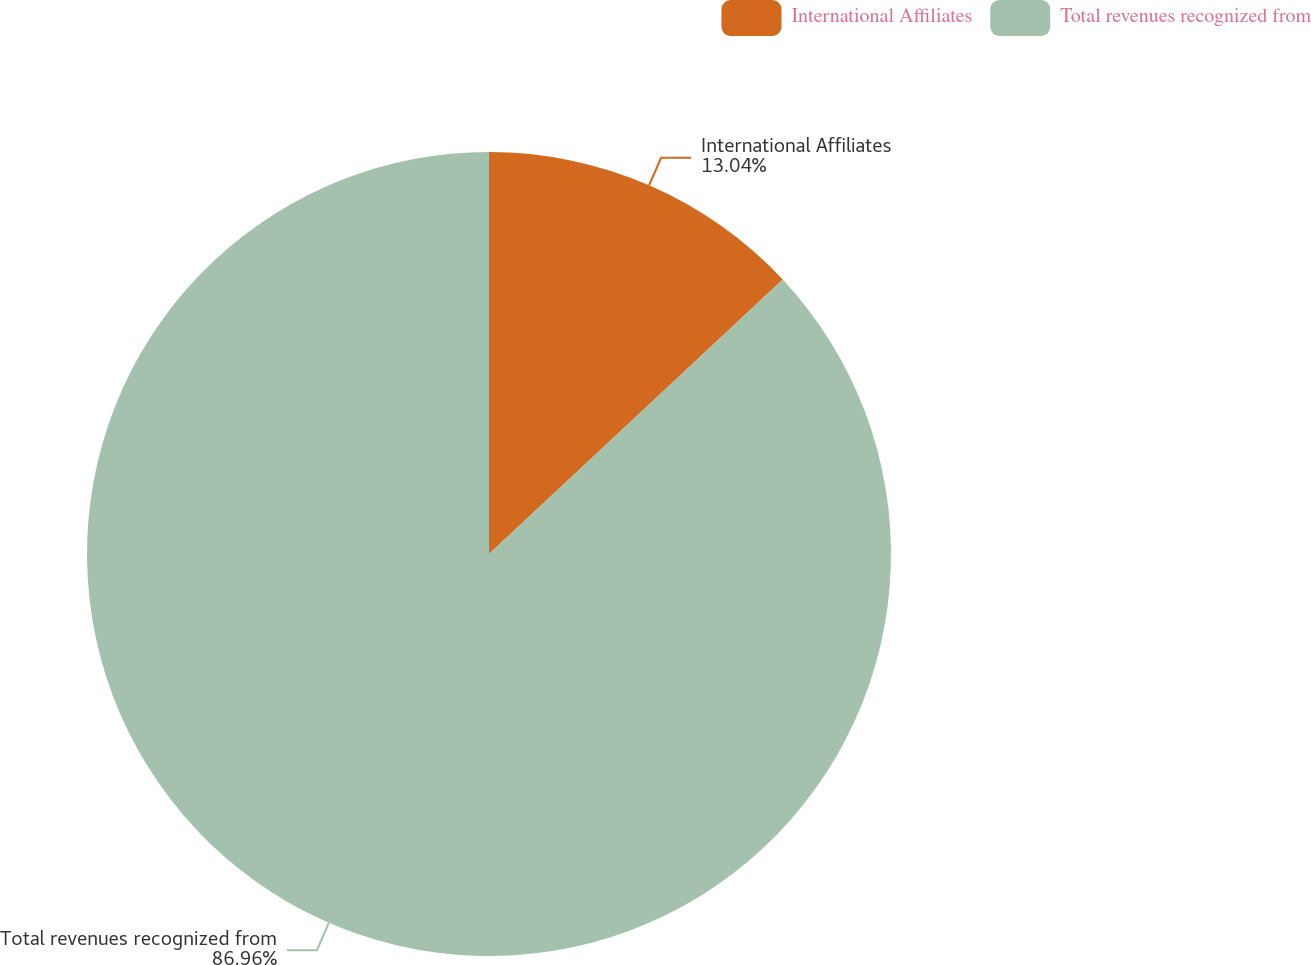Convert chart to OTSL. <chart><loc_0><loc_0><loc_500><loc_500><pie_chart><fcel>International Affiliates<fcel>Total revenues recognized from<nl><fcel>13.04%<fcel>86.96%<nl></chart> 